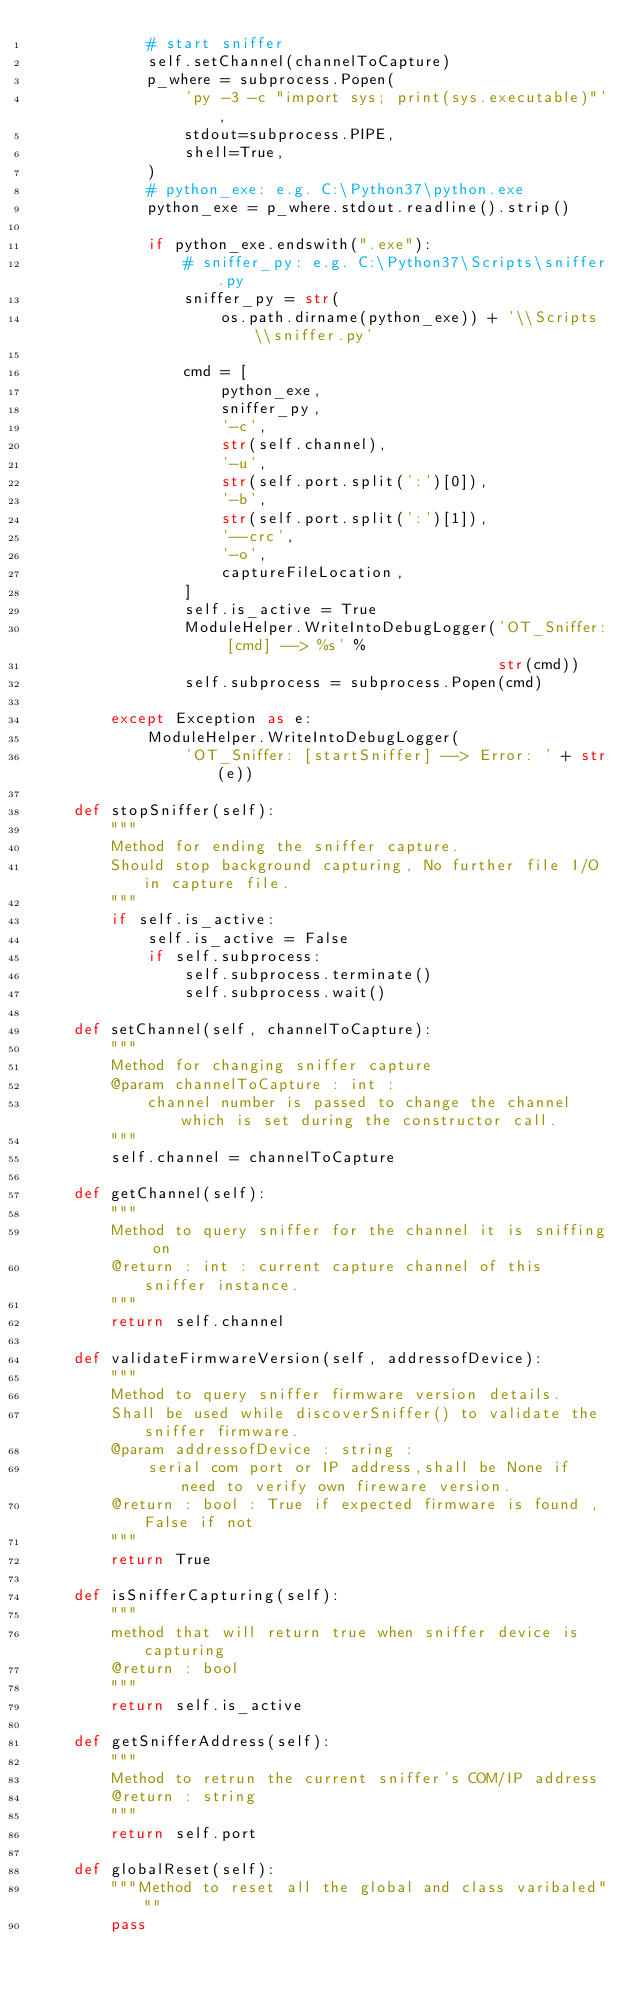<code> <loc_0><loc_0><loc_500><loc_500><_Python_>            # start sniffer
            self.setChannel(channelToCapture)
            p_where = subprocess.Popen(
                'py -3 -c "import sys; print(sys.executable)"',
                stdout=subprocess.PIPE,
                shell=True,
            )
            # python_exe: e.g. C:\Python37\python.exe
            python_exe = p_where.stdout.readline().strip()

            if python_exe.endswith(".exe"):
                # sniffer_py: e.g. C:\Python37\Scripts\sniffer.py
                sniffer_py = str(
                    os.path.dirname(python_exe)) + '\\Scripts\\sniffer.py'

                cmd = [
                    python_exe,
                    sniffer_py,
                    '-c',
                    str(self.channel),
                    '-u',
                    str(self.port.split(':')[0]),
                    '-b',
                    str(self.port.split(':')[1]),
                    '--crc',
                    '-o',
                    captureFileLocation,
                ]
                self.is_active = True
                ModuleHelper.WriteIntoDebugLogger('OT_Sniffer: [cmd] --> %s' %
                                                  str(cmd))
                self.subprocess = subprocess.Popen(cmd)

        except Exception as e:
            ModuleHelper.WriteIntoDebugLogger(
                'OT_Sniffer: [startSniffer] --> Error: ' + str(e))

    def stopSniffer(self):
        """
        Method for ending the sniffer capture.
        Should stop background capturing, No further file I/O in capture file.
        """
        if self.is_active:
            self.is_active = False
            if self.subprocess:
                self.subprocess.terminate()
                self.subprocess.wait()

    def setChannel(self, channelToCapture):
        """
        Method for changing sniffer capture
        @param channelToCapture : int :
            channel number is passed to change the channel which is set during the constructor call.
        """
        self.channel = channelToCapture

    def getChannel(self):
        """
        Method to query sniffer for the channel it is sniffing on
        @return : int : current capture channel of this sniffer instance.
        """
        return self.channel

    def validateFirmwareVersion(self, addressofDevice):
        """
        Method to query sniffer firmware version details.
        Shall be used while discoverSniffer() to validate the sniffer firmware.
        @param addressofDevice : string :
            serial com port or IP address,shall be None if need to verify own fireware version.
        @return : bool : True if expected firmware is found , False if not
        """
        return True

    def isSnifferCapturing(self):
        """
        method that will return true when sniffer device is capturing
        @return : bool
        """
        return self.is_active

    def getSnifferAddress(self):
        """
        Method to retrun the current sniffer's COM/IP address
        @return : string
        """
        return self.port

    def globalReset(self):
        """Method to reset all the global and class varibaled"""
        pass
</code> 